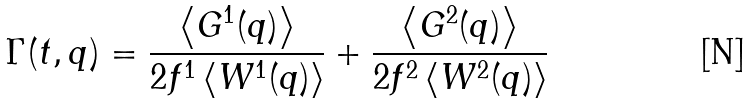Convert formula to latex. <formula><loc_0><loc_0><loc_500><loc_500>\Gamma ( t , q ) = \frac { \left \langle G ^ { 1 } ( { q } ) \right \rangle } { 2 f ^ { 1 } \left \langle W ^ { 1 } ( { q } ) \right \rangle } + \frac { \left \langle G ^ { 2 } ( { q } ) \right \rangle } { 2 f ^ { 2 } \left \langle W ^ { 2 } ( { q } ) \right \rangle }</formula> 